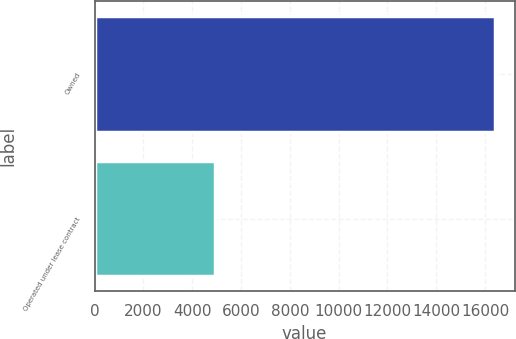Convert chart. <chart><loc_0><loc_0><loc_500><loc_500><bar_chart><fcel>Owned<fcel>Operated under lease contract<nl><fcel>16389<fcel>4947<nl></chart> 